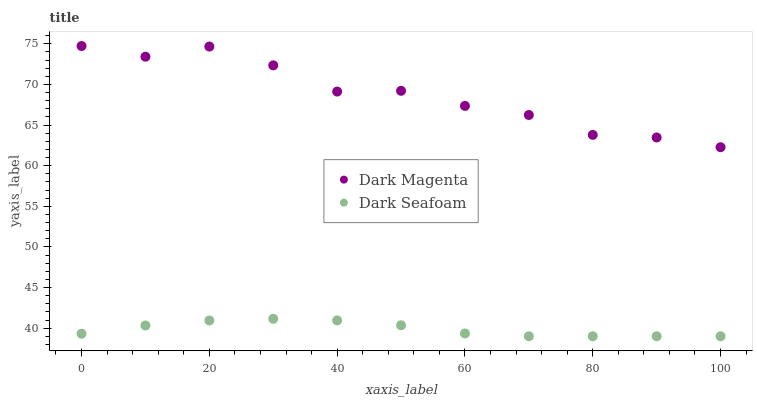Does Dark Seafoam have the minimum area under the curve?
Answer yes or no. Yes. Does Dark Magenta have the maximum area under the curve?
Answer yes or no. Yes. Does Dark Magenta have the minimum area under the curve?
Answer yes or no. No. Is Dark Seafoam the smoothest?
Answer yes or no. Yes. Is Dark Magenta the roughest?
Answer yes or no. Yes. Is Dark Magenta the smoothest?
Answer yes or no. No. Does Dark Seafoam have the lowest value?
Answer yes or no. Yes. Does Dark Magenta have the lowest value?
Answer yes or no. No. Does Dark Magenta have the highest value?
Answer yes or no. Yes. Is Dark Seafoam less than Dark Magenta?
Answer yes or no. Yes. Is Dark Magenta greater than Dark Seafoam?
Answer yes or no. Yes. Does Dark Seafoam intersect Dark Magenta?
Answer yes or no. No. 